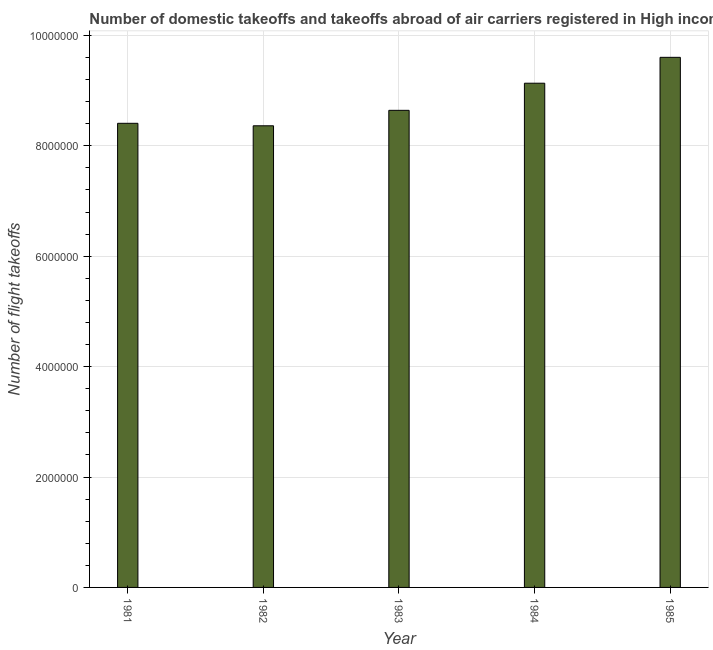Does the graph contain any zero values?
Provide a succinct answer. No. What is the title of the graph?
Keep it short and to the point. Number of domestic takeoffs and takeoffs abroad of air carriers registered in High income. What is the label or title of the X-axis?
Ensure brevity in your answer.  Year. What is the label or title of the Y-axis?
Offer a terse response. Number of flight takeoffs. What is the number of flight takeoffs in 1981?
Make the answer very short. 8.41e+06. Across all years, what is the maximum number of flight takeoffs?
Your answer should be compact. 9.60e+06. Across all years, what is the minimum number of flight takeoffs?
Give a very brief answer. 8.36e+06. In which year was the number of flight takeoffs minimum?
Offer a very short reply. 1982. What is the sum of the number of flight takeoffs?
Your answer should be very brief. 4.41e+07. What is the difference between the number of flight takeoffs in 1983 and 1985?
Your answer should be compact. -9.60e+05. What is the average number of flight takeoffs per year?
Your response must be concise. 8.83e+06. What is the median number of flight takeoffs?
Your answer should be compact. 8.64e+06. In how many years, is the number of flight takeoffs greater than 800000 ?
Offer a very short reply. 5. What is the ratio of the number of flight takeoffs in 1982 to that in 1983?
Offer a terse response. 0.97. Is the number of flight takeoffs in 1984 less than that in 1985?
Provide a succinct answer. Yes. Is the difference between the number of flight takeoffs in 1982 and 1983 greater than the difference between any two years?
Your response must be concise. No. What is the difference between the highest and the second highest number of flight takeoffs?
Your answer should be very brief. 4.69e+05. What is the difference between the highest and the lowest number of flight takeoffs?
Your response must be concise. 1.24e+06. How many bars are there?
Offer a terse response. 5. Are all the bars in the graph horizontal?
Provide a short and direct response. No. What is the difference between two consecutive major ticks on the Y-axis?
Make the answer very short. 2.00e+06. What is the Number of flight takeoffs in 1981?
Offer a terse response. 8.41e+06. What is the Number of flight takeoffs of 1982?
Ensure brevity in your answer.  8.36e+06. What is the Number of flight takeoffs of 1983?
Offer a very short reply. 8.64e+06. What is the Number of flight takeoffs in 1984?
Give a very brief answer. 9.13e+06. What is the Number of flight takeoffs in 1985?
Provide a succinct answer. 9.60e+06. What is the difference between the Number of flight takeoffs in 1981 and 1982?
Provide a succinct answer. 4.49e+04. What is the difference between the Number of flight takeoffs in 1981 and 1983?
Give a very brief answer. -2.35e+05. What is the difference between the Number of flight takeoffs in 1981 and 1984?
Your response must be concise. -7.26e+05. What is the difference between the Number of flight takeoffs in 1981 and 1985?
Keep it short and to the point. -1.20e+06. What is the difference between the Number of flight takeoffs in 1982 and 1983?
Offer a very short reply. -2.80e+05. What is the difference between the Number of flight takeoffs in 1982 and 1984?
Make the answer very short. -7.71e+05. What is the difference between the Number of flight takeoffs in 1982 and 1985?
Your answer should be very brief. -1.24e+06. What is the difference between the Number of flight takeoffs in 1983 and 1984?
Keep it short and to the point. -4.91e+05. What is the difference between the Number of flight takeoffs in 1983 and 1985?
Keep it short and to the point. -9.60e+05. What is the difference between the Number of flight takeoffs in 1984 and 1985?
Make the answer very short. -4.69e+05. What is the ratio of the Number of flight takeoffs in 1981 to that in 1982?
Your response must be concise. 1. What is the ratio of the Number of flight takeoffs in 1981 to that in 1984?
Your answer should be compact. 0.92. What is the ratio of the Number of flight takeoffs in 1981 to that in 1985?
Provide a short and direct response. 0.88. What is the ratio of the Number of flight takeoffs in 1982 to that in 1983?
Provide a succinct answer. 0.97. What is the ratio of the Number of flight takeoffs in 1982 to that in 1984?
Provide a short and direct response. 0.92. What is the ratio of the Number of flight takeoffs in 1982 to that in 1985?
Your answer should be compact. 0.87. What is the ratio of the Number of flight takeoffs in 1983 to that in 1984?
Your response must be concise. 0.95. What is the ratio of the Number of flight takeoffs in 1983 to that in 1985?
Keep it short and to the point. 0.9. What is the ratio of the Number of flight takeoffs in 1984 to that in 1985?
Your answer should be compact. 0.95. 